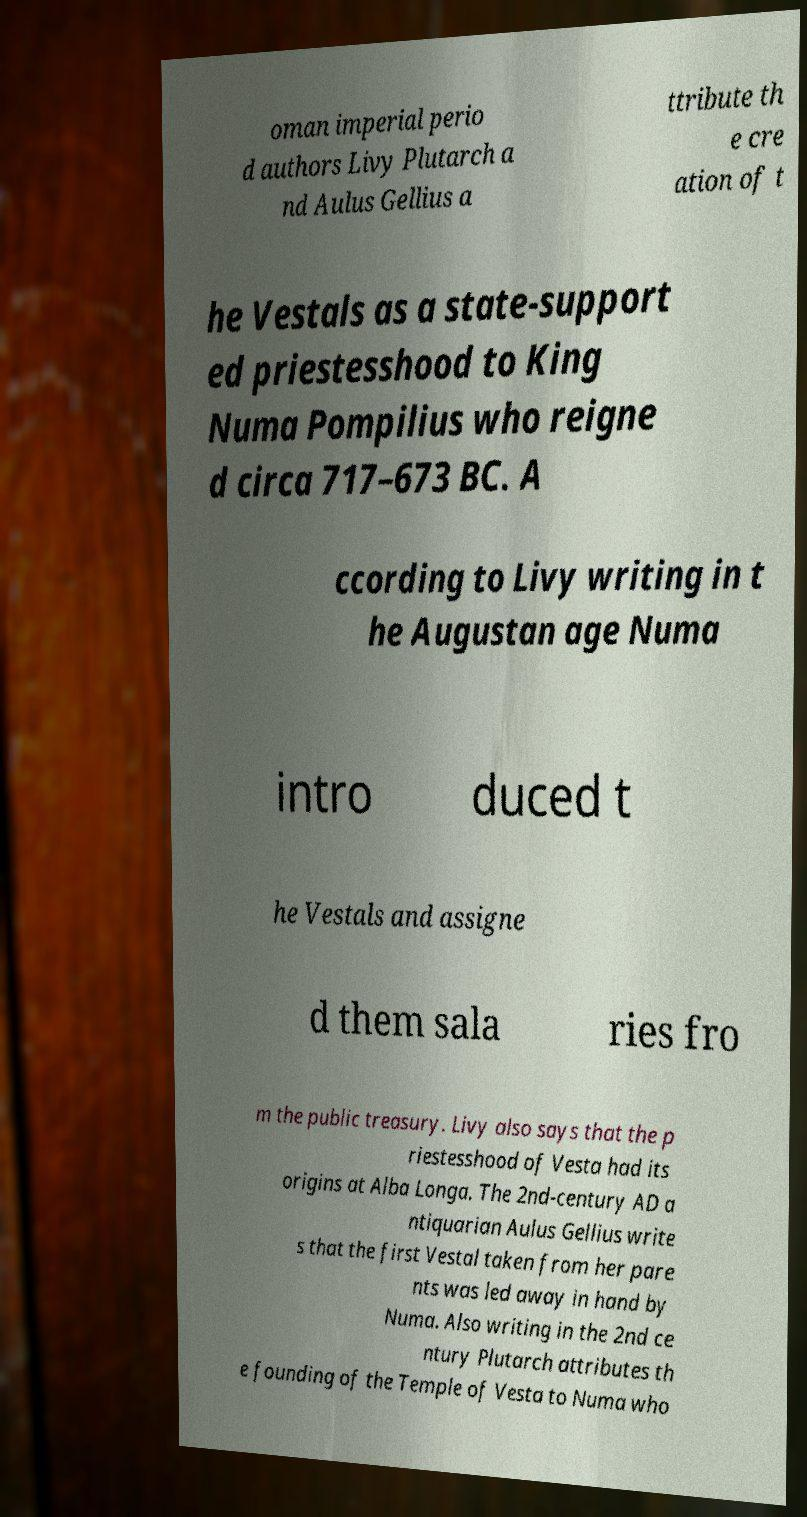Can you read and provide the text displayed in the image?This photo seems to have some interesting text. Can you extract and type it out for me? oman imperial perio d authors Livy Plutarch a nd Aulus Gellius a ttribute th e cre ation of t he Vestals as a state-support ed priestesshood to King Numa Pompilius who reigne d circa 717–673 BC. A ccording to Livy writing in t he Augustan age Numa intro duced t he Vestals and assigne d them sala ries fro m the public treasury. Livy also says that the p riestesshood of Vesta had its origins at Alba Longa. The 2nd-century AD a ntiquarian Aulus Gellius write s that the first Vestal taken from her pare nts was led away in hand by Numa. Also writing in the 2nd ce ntury Plutarch attributes th e founding of the Temple of Vesta to Numa who 